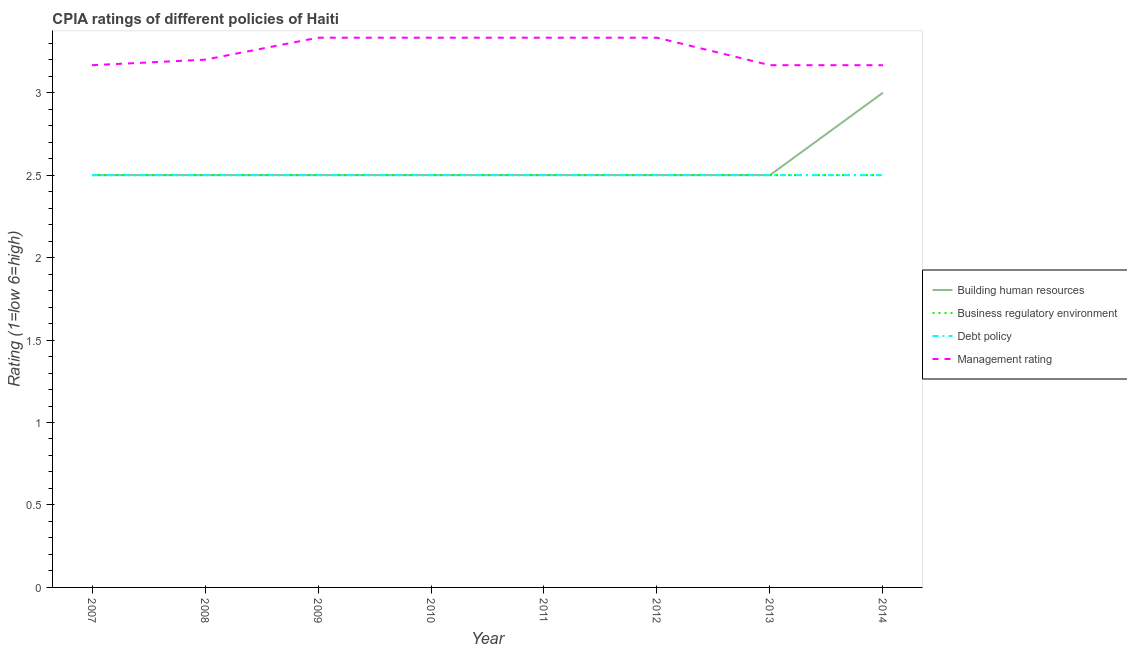How many different coloured lines are there?
Ensure brevity in your answer.  4. Is the number of lines equal to the number of legend labels?
Offer a very short reply. Yes. What is the cpia rating of building human resources in 2012?
Provide a short and direct response. 2.5. Across all years, what is the maximum cpia rating of business regulatory environment?
Offer a very short reply. 2.5. Across all years, what is the minimum cpia rating of building human resources?
Offer a very short reply. 2.5. In which year was the cpia rating of management maximum?
Your answer should be very brief. 2009. What is the total cpia rating of debt policy in the graph?
Offer a very short reply. 20. What is the difference between the cpia rating of business regulatory environment in 2012 and that in 2013?
Keep it short and to the point. 0. In the year 2009, what is the difference between the cpia rating of debt policy and cpia rating of management?
Offer a very short reply. -0.83. In how many years, is the cpia rating of debt policy greater than 1.5?
Provide a succinct answer. 8. Is the difference between the cpia rating of debt policy in 2012 and 2014 greater than the difference between the cpia rating of building human resources in 2012 and 2014?
Your response must be concise. Yes. What is the difference between the highest and the second highest cpia rating of building human resources?
Make the answer very short. 0.5. What is the difference between the highest and the lowest cpia rating of management?
Offer a very short reply. 0.17. Is the sum of the cpia rating of debt policy in 2007 and 2009 greater than the maximum cpia rating of business regulatory environment across all years?
Offer a very short reply. Yes. Is it the case that in every year, the sum of the cpia rating of building human resources and cpia rating of management is greater than the sum of cpia rating of debt policy and cpia rating of business regulatory environment?
Provide a short and direct response. Yes. Is it the case that in every year, the sum of the cpia rating of building human resources and cpia rating of business regulatory environment is greater than the cpia rating of debt policy?
Offer a very short reply. Yes. Does the cpia rating of management monotonically increase over the years?
Your response must be concise. No. Is the cpia rating of management strictly less than the cpia rating of business regulatory environment over the years?
Your answer should be very brief. No. How many lines are there?
Ensure brevity in your answer.  4. Are the values on the major ticks of Y-axis written in scientific E-notation?
Keep it short and to the point. No. Does the graph contain any zero values?
Your response must be concise. No. Does the graph contain grids?
Your answer should be very brief. No. Where does the legend appear in the graph?
Give a very brief answer. Center right. What is the title of the graph?
Keep it short and to the point. CPIA ratings of different policies of Haiti. Does "Taxes on exports" appear as one of the legend labels in the graph?
Offer a very short reply. No. What is the label or title of the Y-axis?
Provide a short and direct response. Rating (1=low 6=high). What is the Rating (1=low 6=high) in Building human resources in 2007?
Provide a succinct answer. 2.5. What is the Rating (1=low 6=high) of Management rating in 2007?
Provide a short and direct response. 3.17. What is the Rating (1=low 6=high) of Management rating in 2008?
Make the answer very short. 3.2. What is the Rating (1=low 6=high) in Management rating in 2009?
Provide a short and direct response. 3.33. What is the Rating (1=low 6=high) in Building human resources in 2010?
Your answer should be very brief. 2.5. What is the Rating (1=low 6=high) of Debt policy in 2010?
Give a very brief answer. 2.5. What is the Rating (1=low 6=high) in Management rating in 2010?
Provide a short and direct response. 3.33. What is the Rating (1=low 6=high) of Building human resources in 2011?
Offer a very short reply. 2.5. What is the Rating (1=low 6=high) in Debt policy in 2011?
Keep it short and to the point. 2.5. What is the Rating (1=low 6=high) of Management rating in 2011?
Your response must be concise. 3.33. What is the Rating (1=low 6=high) in Debt policy in 2012?
Make the answer very short. 2.5. What is the Rating (1=low 6=high) in Management rating in 2012?
Make the answer very short. 3.33. What is the Rating (1=low 6=high) in Business regulatory environment in 2013?
Your answer should be compact. 2.5. What is the Rating (1=low 6=high) of Management rating in 2013?
Your answer should be very brief. 3.17. What is the Rating (1=low 6=high) of Business regulatory environment in 2014?
Give a very brief answer. 2.5. What is the Rating (1=low 6=high) in Management rating in 2014?
Offer a terse response. 3.17. Across all years, what is the maximum Rating (1=low 6=high) in Debt policy?
Your answer should be very brief. 2.5. Across all years, what is the maximum Rating (1=low 6=high) of Management rating?
Provide a short and direct response. 3.33. Across all years, what is the minimum Rating (1=low 6=high) of Debt policy?
Offer a very short reply. 2.5. Across all years, what is the minimum Rating (1=low 6=high) in Management rating?
Ensure brevity in your answer.  3.17. What is the total Rating (1=low 6=high) of Building human resources in the graph?
Make the answer very short. 20.5. What is the total Rating (1=low 6=high) of Debt policy in the graph?
Give a very brief answer. 20. What is the total Rating (1=low 6=high) in Management rating in the graph?
Your answer should be compact. 26.03. What is the difference between the Rating (1=low 6=high) in Building human resources in 2007 and that in 2008?
Your answer should be compact. 0. What is the difference between the Rating (1=low 6=high) of Debt policy in 2007 and that in 2008?
Your response must be concise. 0. What is the difference between the Rating (1=low 6=high) in Management rating in 2007 and that in 2008?
Provide a succinct answer. -0.03. What is the difference between the Rating (1=low 6=high) in Debt policy in 2007 and that in 2009?
Your response must be concise. 0. What is the difference between the Rating (1=low 6=high) of Management rating in 2007 and that in 2009?
Offer a very short reply. -0.17. What is the difference between the Rating (1=low 6=high) in Building human resources in 2007 and that in 2010?
Give a very brief answer. 0. What is the difference between the Rating (1=low 6=high) in Business regulatory environment in 2007 and that in 2010?
Provide a short and direct response. 0. What is the difference between the Rating (1=low 6=high) in Debt policy in 2007 and that in 2010?
Offer a terse response. 0. What is the difference between the Rating (1=low 6=high) in Management rating in 2007 and that in 2010?
Offer a very short reply. -0.17. What is the difference between the Rating (1=low 6=high) in Building human resources in 2007 and that in 2011?
Make the answer very short. 0. What is the difference between the Rating (1=low 6=high) in Debt policy in 2007 and that in 2011?
Your answer should be compact. 0. What is the difference between the Rating (1=low 6=high) of Building human resources in 2007 and that in 2012?
Your answer should be compact. 0. What is the difference between the Rating (1=low 6=high) of Business regulatory environment in 2007 and that in 2012?
Your answer should be compact. 0. What is the difference between the Rating (1=low 6=high) of Debt policy in 2007 and that in 2012?
Your answer should be very brief. 0. What is the difference between the Rating (1=low 6=high) of Management rating in 2007 and that in 2012?
Provide a short and direct response. -0.17. What is the difference between the Rating (1=low 6=high) of Building human resources in 2007 and that in 2013?
Provide a short and direct response. 0. What is the difference between the Rating (1=low 6=high) of Business regulatory environment in 2007 and that in 2013?
Your answer should be compact. 0. What is the difference between the Rating (1=low 6=high) in Debt policy in 2007 and that in 2013?
Offer a very short reply. 0. What is the difference between the Rating (1=low 6=high) in Management rating in 2007 and that in 2013?
Ensure brevity in your answer.  0. What is the difference between the Rating (1=low 6=high) of Building human resources in 2007 and that in 2014?
Provide a short and direct response. -0.5. What is the difference between the Rating (1=low 6=high) in Business regulatory environment in 2007 and that in 2014?
Give a very brief answer. 0. What is the difference between the Rating (1=low 6=high) of Debt policy in 2007 and that in 2014?
Your answer should be very brief. 0. What is the difference between the Rating (1=low 6=high) of Management rating in 2007 and that in 2014?
Make the answer very short. -0. What is the difference between the Rating (1=low 6=high) in Business regulatory environment in 2008 and that in 2009?
Give a very brief answer. 0. What is the difference between the Rating (1=low 6=high) of Management rating in 2008 and that in 2009?
Provide a short and direct response. -0.13. What is the difference between the Rating (1=low 6=high) in Debt policy in 2008 and that in 2010?
Keep it short and to the point. 0. What is the difference between the Rating (1=low 6=high) of Management rating in 2008 and that in 2010?
Your answer should be compact. -0.13. What is the difference between the Rating (1=low 6=high) in Debt policy in 2008 and that in 2011?
Provide a succinct answer. 0. What is the difference between the Rating (1=low 6=high) in Management rating in 2008 and that in 2011?
Your response must be concise. -0.13. What is the difference between the Rating (1=low 6=high) in Business regulatory environment in 2008 and that in 2012?
Provide a short and direct response. 0. What is the difference between the Rating (1=low 6=high) in Management rating in 2008 and that in 2012?
Give a very brief answer. -0.13. What is the difference between the Rating (1=low 6=high) of Building human resources in 2008 and that in 2013?
Provide a succinct answer. 0. What is the difference between the Rating (1=low 6=high) in Business regulatory environment in 2008 and that in 2013?
Your answer should be very brief. 0. What is the difference between the Rating (1=low 6=high) of Building human resources in 2008 and that in 2014?
Offer a terse response. -0.5. What is the difference between the Rating (1=low 6=high) of Business regulatory environment in 2008 and that in 2014?
Your answer should be compact. 0. What is the difference between the Rating (1=low 6=high) in Debt policy in 2008 and that in 2014?
Provide a succinct answer. 0. What is the difference between the Rating (1=low 6=high) in Management rating in 2008 and that in 2014?
Make the answer very short. 0.03. What is the difference between the Rating (1=low 6=high) in Building human resources in 2009 and that in 2010?
Ensure brevity in your answer.  0. What is the difference between the Rating (1=low 6=high) in Debt policy in 2009 and that in 2010?
Your answer should be compact. 0. What is the difference between the Rating (1=low 6=high) of Management rating in 2009 and that in 2011?
Your response must be concise. 0. What is the difference between the Rating (1=low 6=high) of Business regulatory environment in 2009 and that in 2012?
Provide a succinct answer. 0. What is the difference between the Rating (1=low 6=high) of Debt policy in 2009 and that in 2012?
Make the answer very short. 0. What is the difference between the Rating (1=low 6=high) in Building human resources in 2009 and that in 2013?
Ensure brevity in your answer.  0. What is the difference between the Rating (1=low 6=high) in Business regulatory environment in 2009 and that in 2013?
Provide a succinct answer. 0. What is the difference between the Rating (1=low 6=high) in Debt policy in 2009 and that in 2013?
Provide a short and direct response. 0. What is the difference between the Rating (1=low 6=high) in Management rating in 2009 and that in 2013?
Make the answer very short. 0.17. What is the difference between the Rating (1=low 6=high) of Building human resources in 2009 and that in 2014?
Your answer should be compact. -0.5. What is the difference between the Rating (1=low 6=high) of Debt policy in 2009 and that in 2014?
Ensure brevity in your answer.  0. What is the difference between the Rating (1=low 6=high) in Building human resources in 2010 and that in 2011?
Your answer should be compact. 0. What is the difference between the Rating (1=low 6=high) in Debt policy in 2010 and that in 2012?
Ensure brevity in your answer.  0. What is the difference between the Rating (1=low 6=high) in Management rating in 2010 and that in 2012?
Offer a very short reply. 0. What is the difference between the Rating (1=low 6=high) in Building human resources in 2010 and that in 2013?
Offer a very short reply. 0. What is the difference between the Rating (1=low 6=high) of Management rating in 2010 and that in 2013?
Your answer should be compact. 0.17. What is the difference between the Rating (1=low 6=high) in Business regulatory environment in 2010 and that in 2014?
Ensure brevity in your answer.  0. What is the difference between the Rating (1=low 6=high) in Business regulatory environment in 2011 and that in 2012?
Your answer should be very brief. 0. What is the difference between the Rating (1=low 6=high) in Debt policy in 2011 and that in 2012?
Make the answer very short. 0. What is the difference between the Rating (1=low 6=high) of Management rating in 2011 and that in 2012?
Your answer should be very brief. 0. What is the difference between the Rating (1=low 6=high) in Building human resources in 2011 and that in 2014?
Keep it short and to the point. -0.5. What is the difference between the Rating (1=low 6=high) of Business regulatory environment in 2011 and that in 2014?
Offer a very short reply. 0. What is the difference between the Rating (1=low 6=high) in Debt policy in 2011 and that in 2014?
Provide a succinct answer. 0. What is the difference between the Rating (1=low 6=high) of Management rating in 2011 and that in 2014?
Your response must be concise. 0.17. What is the difference between the Rating (1=low 6=high) in Building human resources in 2012 and that in 2013?
Provide a succinct answer. 0. What is the difference between the Rating (1=low 6=high) in Business regulatory environment in 2012 and that in 2013?
Your answer should be very brief. 0. What is the difference between the Rating (1=low 6=high) in Management rating in 2012 and that in 2013?
Provide a short and direct response. 0.17. What is the difference between the Rating (1=low 6=high) in Debt policy in 2012 and that in 2014?
Keep it short and to the point. 0. What is the difference between the Rating (1=low 6=high) in Building human resources in 2013 and that in 2014?
Your response must be concise. -0.5. What is the difference between the Rating (1=low 6=high) of Debt policy in 2013 and that in 2014?
Your response must be concise. 0. What is the difference between the Rating (1=low 6=high) in Building human resources in 2007 and the Rating (1=low 6=high) in Business regulatory environment in 2008?
Offer a very short reply. 0. What is the difference between the Rating (1=low 6=high) in Building human resources in 2007 and the Rating (1=low 6=high) in Management rating in 2008?
Provide a succinct answer. -0.7. What is the difference between the Rating (1=low 6=high) of Debt policy in 2007 and the Rating (1=low 6=high) of Management rating in 2008?
Provide a succinct answer. -0.7. What is the difference between the Rating (1=low 6=high) of Building human resources in 2007 and the Rating (1=low 6=high) of Business regulatory environment in 2009?
Provide a short and direct response. 0. What is the difference between the Rating (1=low 6=high) in Building human resources in 2007 and the Rating (1=low 6=high) in Debt policy in 2009?
Provide a short and direct response. 0. What is the difference between the Rating (1=low 6=high) of Building human resources in 2007 and the Rating (1=low 6=high) of Management rating in 2009?
Provide a succinct answer. -0.83. What is the difference between the Rating (1=low 6=high) in Business regulatory environment in 2007 and the Rating (1=low 6=high) in Debt policy in 2009?
Ensure brevity in your answer.  0. What is the difference between the Rating (1=low 6=high) of Debt policy in 2007 and the Rating (1=low 6=high) of Management rating in 2009?
Your response must be concise. -0.83. What is the difference between the Rating (1=low 6=high) of Building human resources in 2007 and the Rating (1=low 6=high) of Business regulatory environment in 2010?
Offer a terse response. 0. What is the difference between the Rating (1=low 6=high) in Building human resources in 2007 and the Rating (1=low 6=high) in Debt policy in 2010?
Offer a very short reply. 0. What is the difference between the Rating (1=low 6=high) of Building human resources in 2007 and the Rating (1=low 6=high) of Management rating in 2010?
Provide a succinct answer. -0.83. What is the difference between the Rating (1=low 6=high) in Building human resources in 2007 and the Rating (1=low 6=high) in Business regulatory environment in 2011?
Your answer should be compact. 0. What is the difference between the Rating (1=low 6=high) of Building human resources in 2007 and the Rating (1=low 6=high) of Debt policy in 2011?
Provide a succinct answer. 0. What is the difference between the Rating (1=low 6=high) in Business regulatory environment in 2007 and the Rating (1=low 6=high) in Debt policy in 2011?
Provide a short and direct response. 0. What is the difference between the Rating (1=low 6=high) in Business regulatory environment in 2007 and the Rating (1=low 6=high) in Management rating in 2011?
Keep it short and to the point. -0.83. What is the difference between the Rating (1=low 6=high) in Building human resources in 2007 and the Rating (1=low 6=high) in Business regulatory environment in 2012?
Provide a short and direct response. 0. What is the difference between the Rating (1=low 6=high) in Building human resources in 2007 and the Rating (1=low 6=high) in Debt policy in 2012?
Ensure brevity in your answer.  0. What is the difference between the Rating (1=low 6=high) of Building human resources in 2007 and the Rating (1=low 6=high) of Management rating in 2012?
Your answer should be compact. -0.83. What is the difference between the Rating (1=low 6=high) of Business regulatory environment in 2007 and the Rating (1=low 6=high) of Debt policy in 2012?
Provide a succinct answer. 0. What is the difference between the Rating (1=low 6=high) of Business regulatory environment in 2007 and the Rating (1=low 6=high) of Management rating in 2012?
Give a very brief answer. -0.83. What is the difference between the Rating (1=low 6=high) in Business regulatory environment in 2007 and the Rating (1=low 6=high) in Debt policy in 2013?
Keep it short and to the point. 0. What is the difference between the Rating (1=low 6=high) in Debt policy in 2007 and the Rating (1=low 6=high) in Management rating in 2013?
Your answer should be compact. -0.67. What is the difference between the Rating (1=low 6=high) of Business regulatory environment in 2007 and the Rating (1=low 6=high) of Debt policy in 2014?
Offer a very short reply. 0. What is the difference between the Rating (1=low 6=high) in Business regulatory environment in 2007 and the Rating (1=low 6=high) in Management rating in 2014?
Provide a short and direct response. -0.67. What is the difference between the Rating (1=low 6=high) in Building human resources in 2008 and the Rating (1=low 6=high) in Management rating in 2009?
Your answer should be very brief. -0.83. What is the difference between the Rating (1=low 6=high) in Business regulatory environment in 2008 and the Rating (1=low 6=high) in Debt policy in 2009?
Provide a short and direct response. 0. What is the difference between the Rating (1=low 6=high) of Business regulatory environment in 2008 and the Rating (1=low 6=high) of Management rating in 2009?
Ensure brevity in your answer.  -0.83. What is the difference between the Rating (1=low 6=high) of Debt policy in 2008 and the Rating (1=low 6=high) of Management rating in 2009?
Offer a very short reply. -0.83. What is the difference between the Rating (1=low 6=high) of Building human resources in 2008 and the Rating (1=low 6=high) of Debt policy in 2010?
Provide a succinct answer. 0. What is the difference between the Rating (1=low 6=high) in Building human resources in 2008 and the Rating (1=low 6=high) in Management rating in 2010?
Give a very brief answer. -0.83. What is the difference between the Rating (1=low 6=high) in Business regulatory environment in 2008 and the Rating (1=low 6=high) in Management rating in 2010?
Offer a very short reply. -0.83. What is the difference between the Rating (1=low 6=high) in Debt policy in 2008 and the Rating (1=low 6=high) in Management rating in 2010?
Offer a terse response. -0.83. What is the difference between the Rating (1=low 6=high) of Building human resources in 2008 and the Rating (1=low 6=high) of Debt policy in 2011?
Offer a terse response. 0. What is the difference between the Rating (1=low 6=high) of Building human resources in 2008 and the Rating (1=low 6=high) of Management rating in 2011?
Make the answer very short. -0.83. What is the difference between the Rating (1=low 6=high) in Business regulatory environment in 2008 and the Rating (1=low 6=high) in Debt policy in 2011?
Offer a terse response. 0. What is the difference between the Rating (1=low 6=high) in Building human resources in 2008 and the Rating (1=low 6=high) in Business regulatory environment in 2012?
Make the answer very short. 0. What is the difference between the Rating (1=low 6=high) of Building human resources in 2008 and the Rating (1=low 6=high) of Management rating in 2012?
Your answer should be compact. -0.83. What is the difference between the Rating (1=low 6=high) of Business regulatory environment in 2008 and the Rating (1=low 6=high) of Debt policy in 2012?
Your answer should be compact. 0. What is the difference between the Rating (1=low 6=high) in Building human resources in 2008 and the Rating (1=low 6=high) in Business regulatory environment in 2013?
Keep it short and to the point. 0. What is the difference between the Rating (1=low 6=high) in Building human resources in 2008 and the Rating (1=low 6=high) in Debt policy in 2013?
Give a very brief answer. 0. What is the difference between the Rating (1=low 6=high) of Business regulatory environment in 2008 and the Rating (1=low 6=high) of Management rating in 2013?
Your answer should be compact. -0.67. What is the difference between the Rating (1=low 6=high) in Debt policy in 2008 and the Rating (1=low 6=high) in Management rating in 2013?
Give a very brief answer. -0.67. What is the difference between the Rating (1=low 6=high) in Building human resources in 2008 and the Rating (1=low 6=high) in Business regulatory environment in 2014?
Your response must be concise. 0. What is the difference between the Rating (1=low 6=high) of Building human resources in 2008 and the Rating (1=low 6=high) of Debt policy in 2014?
Your answer should be very brief. 0. What is the difference between the Rating (1=low 6=high) in Business regulatory environment in 2008 and the Rating (1=low 6=high) in Debt policy in 2014?
Offer a very short reply. 0. What is the difference between the Rating (1=low 6=high) of Business regulatory environment in 2008 and the Rating (1=low 6=high) of Management rating in 2014?
Your answer should be very brief. -0.67. What is the difference between the Rating (1=low 6=high) in Building human resources in 2009 and the Rating (1=low 6=high) in Debt policy in 2010?
Give a very brief answer. 0. What is the difference between the Rating (1=low 6=high) in Building human resources in 2009 and the Rating (1=low 6=high) in Business regulatory environment in 2011?
Offer a very short reply. 0. What is the difference between the Rating (1=low 6=high) in Building human resources in 2009 and the Rating (1=low 6=high) in Debt policy in 2011?
Provide a short and direct response. 0. What is the difference between the Rating (1=low 6=high) in Building human resources in 2009 and the Rating (1=low 6=high) in Management rating in 2011?
Your response must be concise. -0.83. What is the difference between the Rating (1=low 6=high) of Business regulatory environment in 2009 and the Rating (1=low 6=high) of Debt policy in 2011?
Offer a very short reply. 0. What is the difference between the Rating (1=low 6=high) in Building human resources in 2009 and the Rating (1=low 6=high) in Business regulatory environment in 2012?
Your response must be concise. 0. What is the difference between the Rating (1=low 6=high) of Debt policy in 2009 and the Rating (1=low 6=high) of Management rating in 2012?
Give a very brief answer. -0.83. What is the difference between the Rating (1=low 6=high) in Building human resources in 2009 and the Rating (1=low 6=high) in Business regulatory environment in 2013?
Give a very brief answer. 0. What is the difference between the Rating (1=low 6=high) of Building human resources in 2009 and the Rating (1=low 6=high) of Debt policy in 2013?
Offer a very short reply. 0. What is the difference between the Rating (1=low 6=high) in Business regulatory environment in 2009 and the Rating (1=low 6=high) in Debt policy in 2013?
Provide a short and direct response. 0. What is the difference between the Rating (1=low 6=high) of Business regulatory environment in 2009 and the Rating (1=low 6=high) of Management rating in 2013?
Provide a short and direct response. -0.67. What is the difference between the Rating (1=low 6=high) in Debt policy in 2009 and the Rating (1=low 6=high) in Management rating in 2013?
Your response must be concise. -0.67. What is the difference between the Rating (1=low 6=high) of Building human resources in 2009 and the Rating (1=low 6=high) of Business regulatory environment in 2014?
Your answer should be very brief. 0. What is the difference between the Rating (1=low 6=high) of Building human resources in 2009 and the Rating (1=low 6=high) of Debt policy in 2014?
Provide a succinct answer. 0. What is the difference between the Rating (1=low 6=high) in Building human resources in 2009 and the Rating (1=low 6=high) in Management rating in 2014?
Make the answer very short. -0.67. What is the difference between the Rating (1=low 6=high) of Business regulatory environment in 2009 and the Rating (1=low 6=high) of Debt policy in 2014?
Your answer should be compact. 0. What is the difference between the Rating (1=low 6=high) of Business regulatory environment in 2009 and the Rating (1=low 6=high) of Management rating in 2014?
Give a very brief answer. -0.67. What is the difference between the Rating (1=low 6=high) of Debt policy in 2009 and the Rating (1=low 6=high) of Management rating in 2014?
Your response must be concise. -0.67. What is the difference between the Rating (1=low 6=high) of Building human resources in 2010 and the Rating (1=low 6=high) of Debt policy in 2011?
Provide a succinct answer. 0. What is the difference between the Rating (1=low 6=high) in Building human resources in 2010 and the Rating (1=low 6=high) in Management rating in 2011?
Your answer should be very brief. -0.83. What is the difference between the Rating (1=low 6=high) of Building human resources in 2010 and the Rating (1=low 6=high) of Business regulatory environment in 2012?
Your response must be concise. 0. What is the difference between the Rating (1=low 6=high) of Building human resources in 2010 and the Rating (1=low 6=high) of Management rating in 2012?
Make the answer very short. -0.83. What is the difference between the Rating (1=low 6=high) of Business regulatory environment in 2010 and the Rating (1=low 6=high) of Debt policy in 2012?
Offer a terse response. 0. What is the difference between the Rating (1=low 6=high) in Building human resources in 2010 and the Rating (1=low 6=high) in Business regulatory environment in 2013?
Provide a succinct answer. 0. What is the difference between the Rating (1=low 6=high) of Building human resources in 2010 and the Rating (1=low 6=high) of Debt policy in 2013?
Your answer should be very brief. 0. What is the difference between the Rating (1=low 6=high) in Building human resources in 2010 and the Rating (1=low 6=high) in Management rating in 2013?
Your answer should be very brief. -0.67. What is the difference between the Rating (1=low 6=high) of Business regulatory environment in 2010 and the Rating (1=low 6=high) of Debt policy in 2013?
Make the answer very short. 0. What is the difference between the Rating (1=low 6=high) of Business regulatory environment in 2010 and the Rating (1=low 6=high) of Management rating in 2013?
Your answer should be compact. -0.67. What is the difference between the Rating (1=low 6=high) in Debt policy in 2010 and the Rating (1=low 6=high) in Management rating in 2013?
Your answer should be very brief. -0.67. What is the difference between the Rating (1=low 6=high) of Building human resources in 2010 and the Rating (1=low 6=high) of Management rating in 2014?
Your answer should be compact. -0.67. What is the difference between the Rating (1=low 6=high) of Business regulatory environment in 2010 and the Rating (1=low 6=high) of Management rating in 2014?
Give a very brief answer. -0.67. What is the difference between the Rating (1=low 6=high) of Debt policy in 2010 and the Rating (1=low 6=high) of Management rating in 2014?
Offer a very short reply. -0.67. What is the difference between the Rating (1=low 6=high) of Building human resources in 2011 and the Rating (1=low 6=high) of Management rating in 2012?
Offer a very short reply. -0.83. What is the difference between the Rating (1=low 6=high) in Business regulatory environment in 2011 and the Rating (1=low 6=high) in Debt policy in 2012?
Make the answer very short. 0. What is the difference between the Rating (1=low 6=high) of Building human resources in 2011 and the Rating (1=low 6=high) of Management rating in 2013?
Make the answer very short. -0.67. What is the difference between the Rating (1=low 6=high) in Building human resources in 2011 and the Rating (1=low 6=high) in Business regulatory environment in 2014?
Ensure brevity in your answer.  0. What is the difference between the Rating (1=low 6=high) of Building human resources in 2011 and the Rating (1=low 6=high) of Debt policy in 2014?
Offer a very short reply. 0. What is the difference between the Rating (1=low 6=high) in Building human resources in 2011 and the Rating (1=low 6=high) in Management rating in 2014?
Give a very brief answer. -0.67. What is the difference between the Rating (1=low 6=high) in Business regulatory environment in 2011 and the Rating (1=low 6=high) in Management rating in 2014?
Give a very brief answer. -0.67. What is the difference between the Rating (1=low 6=high) of Building human resources in 2012 and the Rating (1=low 6=high) of Business regulatory environment in 2013?
Ensure brevity in your answer.  0. What is the difference between the Rating (1=low 6=high) in Building human resources in 2012 and the Rating (1=low 6=high) in Debt policy in 2013?
Ensure brevity in your answer.  0. What is the difference between the Rating (1=low 6=high) of Building human resources in 2012 and the Rating (1=low 6=high) of Management rating in 2013?
Your answer should be compact. -0.67. What is the difference between the Rating (1=low 6=high) in Business regulatory environment in 2012 and the Rating (1=low 6=high) in Management rating in 2013?
Your answer should be very brief. -0.67. What is the difference between the Rating (1=low 6=high) of Debt policy in 2012 and the Rating (1=low 6=high) of Management rating in 2013?
Offer a terse response. -0.67. What is the difference between the Rating (1=low 6=high) of Building human resources in 2012 and the Rating (1=low 6=high) of Management rating in 2014?
Ensure brevity in your answer.  -0.67. What is the difference between the Rating (1=low 6=high) in Business regulatory environment in 2012 and the Rating (1=low 6=high) in Debt policy in 2014?
Your answer should be compact. 0. What is the difference between the Rating (1=low 6=high) in Business regulatory environment in 2012 and the Rating (1=low 6=high) in Management rating in 2014?
Provide a short and direct response. -0.67. What is the difference between the Rating (1=low 6=high) in Debt policy in 2012 and the Rating (1=low 6=high) in Management rating in 2014?
Your response must be concise. -0.67. What is the difference between the Rating (1=low 6=high) of Building human resources in 2013 and the Rating (1=low 6=high) of Business regulatory environment in 2014?
Offer a terse response. 0. What is the difference between the Rating (1=low 6=high) in Business regulatory environment in 2013 and the Rating (1=low 6=high) in Debt policy in 2014?
Make the answer very short. 0. What is the average Rating (1=low 6=high) in Building human resources per year?
Offer a terse response. 2.56. What is the average Rating (1=low 6=high) of Management rating per year?
Offer a very short reply. 3.25. In the year 2007, what is the difference between the Rating (1=low 6=high) of Building human resources and Rating (1=low 6=high) of Business regulatory environment?
Ensure brevity in your answer.  0. In the year 2007, what is the difference between the Rating (1=low 6=high) of Building human resources and Rating (1=low 6=high) of Management rating?
Your answer should be compact. -0.67. In the year 2007, what is the difference between the Rating (1=low 6=high) of Business regulatory environment and Rating (1=low 6=high) of Debt policy?
Give a very brief answer. 0. In the year 2007, what is the difference between the Rating (1=low 6=high) of Debt policy and Rating (1=low 6=high) of Management rating?
Give a very brief answer. -0.67. In the year 2008, what is the difference between the Rating (1=low 6=high) of Building human resources and Rating (1=low 6=high) of Debt policy?
Your answer should be compact. 0. In the year 2008, what is the difference between the Rating (1=low 6=high) in Building human resources and Rating (1=low 6=high) in Management rating?
Make the answer very short. -0.7. In the year 2008, what is the difference between the Rating (1=low 6=high) in Business regulatory environment and Rating (1=low 6=high) in Management rating?
Make the answer very short. -0.7. In the year 2008, what is the difference between the Rating (1=low 6=high) of Debt policy and Rating (1=low 6=high) of Management rating?
Give a very brief answer. -0.7. In the year 2009, what is the difference between the Rating (1=low 6=high) of Building human resources and Rating (1=low 6=high) of Business regulatory environment?
Provide a short and direct response. 0. In the year 2009, what is the difference between the Rating (1=low 6=high) in Building human resources and Rating (1=low 6=high) in Management rating?
Offer a terse response. -0.83. In the year 2009, what is the difference between the Rating (1=low 6=high) in Business regulatory environment and Rating (1=low 6=high) in Debt policy?
Make the answer very short. 0. In the year 2009, what is the difference between the Rating (1=low 6=high) of Business regulatory environment and Rating (1=low 6=high) of Management rating?
Give a very brief answer. -0.83. In the year 2009, what is the difference between the Rating (1=low 6=high) of Debt policy and Rating (1=low 6=high) of Management rating?
Give a very brief answer. -0.83. In the year 2010, what is the difference between the Rating (1=low 6=high) of Building human resources and Rating (1=low 6=high) of Debt policy?
Provide a succinct answer. 0. In the year 2010, what is the difference between the Rating (1=low 6=high) in Business regulatory environment and Rating (1=low 6=high) in Debt policy?
Provide a succinct answer. 0. In the year 2010, what is the difference between the Rating (1=low 6=high) in Business regulatory environment and Rating (1=low 6=high) in Management rating?
Offer a very short reply. -0.83. In the year 2011, what is the difference between the Rating (1=low 6=high) of Building human resources and Rating (1=low 6=high) of Business regulatory environment?
Your response must be concise. 0. In the year 2011, what is the difference between the Rating (1=low 6=high) of Building human resources and Rating (1=low 6=high) of Management rating?
Make the answer very short. -0.83. In the year 2011, what is the difference between the Rating (1=low 6=high) of Business regulatory environment and Rating (1=low 6=high) of Debt policy?
Give a very brief answer. 0. In the year 2011, what is the difference between the Rating (1=low 6=high) of Debt policy and Rating (1=low 6=high) of Management rating?
Provide a succinct answer. -0.83. In the year 2012, what is the difference between the Rating (1=low 6=high) in Building human resources and Rating (1=low 6=high) in Business regulatory environment?
Make the answer very short. 0. In the year 2012, what is the difference between the Rating (1=low 6=high) in Building human resources and Rating (1=low 6=high) in Management rating?
Your response must be concise. -0.83. In the year 2012, what is the difference between the Rating (1=low 6=high) of Debt policy and Rating (1=low 6=high) of Management rating?
Keep it short and to the point. -0.83. In the year 2013, what is the difference between the Rating (1=low 6=high) in Building human resources and Rating (1=low 6=high) in Business regulatory environment?
Provide a short and direct response. 0. In the year 2013, what is the difference between the Rating (1=low 6=high) in Building human resources and Rating (1=low 6=high) in Debt policy?
Keep it short and to the point. 0. In the year 2013, what is the difference between the Rating (1=low 6=high) of Building human resources and Rating (1=low 6=high) of Management rating?
Your answer should be very brief. -0.67. In the year 2013, what is the difference between the Rating (1=low 6=high) of Business regulatory environment and Rating (1=low 6=high) of Management rating?
Ensure brevity in your answer.  -0.67. In the year 2014, what is the difference between the Rating (1=low 6=high) in Business regulatory environment and Rating (1=low 6=high) in Management rating?
Ensure brevity in your answer.  -0.67. In the year 2014, what is the difference between the Rating (1=low 6=high) in Debt policy and Rating (1=low 6=high) in Management rating?
Provide a succinct answer. -0.67. What is the ratio of the Rating (1=low 6=high) in Building human resources in 2007 to that in 2008?
Keep it short and to the point. 1. What is the ratio of the Rating (1=low 6=high) of Business regulatory environment in 2007 to that in 2008?
Your response must be concise. 1. What is the ratio of the Rating (1=low 6=high) of Management rating in 2007 to that in 2008?
Ensure brevity in your answer.  0.99. What is the ratio of the Rating (1=low 6=high) of Building human resources in 2007 to that in 2009?
Give a very brief answer. 1. What is the ratio of the Rating (1=low 6=high) in Business regulatory environment in 2007 to that in 2009?
Offer a terse response. 1. What is the ratio of the Rating (1=low 6=high) of Building human resources in 2007 to that in 2010?
Offer a terse response. 1. What is the ratio of the Rating (1=low 6=high) in Debt policy in 2007 to that in 2010?
Provide a succinct answer. 1. What is the ratio of the Rating (1=low 6=high) in Building human resources in 2007 to that in 2011?
Your answer should be compact. 1. What is the ratio of the Rating (1=low 6=high) of Debt policy in 2007 to that in 2011?
Offer a very short reply. 1. What is the ratio of the Rating (1=low 6=high) of Management rating in 2007 to that in 2011?
Give a very brief answer. 0.95. What is the ratio of the Rating (1=low 6=high) of Building human resources in 2007 to that in 2012?
Ensure brevity in your answer.  1. What is the ratio of the Rating (1=low 6=high) of Business regulatory environment in 2007 to that in 2012?
Your answer should be very brief. 1. What is the ratio of the Rating (1=low 6=high) in Management rating in 2007 to that in 2012?
Your answer should be compact. 0.95. What is the ratio of the Rating (1=low 6=high) of Business regulatory environment in 2007 to that in 2013?
Provide a succinct answer. 1. What is the ratio of the Rating (1=low 6=high) in Management rating in 2007 to that in 2013?
Make the answer very short. 1. What is the ratio of the Rating (1=low 6=high) of Building human resources in 2007 to that in 2014?
Offer a very short reply. 0.83. What is the ratio of the Rating (1=low 6=high) in Debt policy in 2008 to that in 2009?
Offer a very short reply. 1. What is the ratio of the Rating (1=low 6=high) of Building human resources in 2008 to that in 2010?
Give a very brief answer. 1. What is the ratio of the Rating (1=low 6=high) of Business regulatory environment in 2008 to that in 2010?
Your response must be concise. 1. What is the ratio of the Rating (1=low 6=high) in Management rating in 2008 to that in 2010?
Keep it short and to the point. 0.96. What is the ratio of the Rating (1=low 6=high) of Business regulatory environment in 2008 to that in 2011?
Ensure brevity in your answer.  1. What is the ratio of the Rating (1=low 6=high) of Debt policy in 2008 to that in 2011?
Provide a short and direct response. 1. What is the ratio of the Rating (1=low 6=high) in Business regulatory environment in 2008 to that in 2012?
Ensure brevity in your answer.  1. What is the ratio of the Rating (1=low 6=high) of Management rating in 2008 to that in 2012?
Your response must be concise. 0.96. What is the ratio of the Rating (1=low 6=high) in Management rating in 2008 to that in 2013?
Give a very brief answer. 1.01. What is the ratio of the Rating (1=low 6=high) in Debt policy in 2008 to that in 2014?
Offer a terse response. 1. What is the ratio of the Rating (1=low 6=high) of Management rating in 2008 to that in 2014?
Keep it short and to the point. 1.01. What is the ratio of the Rating (1=low 6=high) of Building human resources in 2009 to that in 2010?
Your response must be concise. 1. What is the ratio of the Rating (1=low 6=high) in Business regulatory environment in 2009 to that in 2010?
Make the answer very short. 1. What is the ratio of the Rating (1=low 6=high) in Building human resources in 2009 to that in 2011?
Your answer should be very brief. 1. What is the ratio of the Rating (1=low 6=high) in Debt policy in 2009 to that in 2011?
Ensure brevity in your answer.  1. What is the ratio of the Rating (1=low 6=high) of Management rating in 2009 to that in 2011?
Make the answer very short. 1. What is the ratio of the Rating (1=low 6=high) of Building human resources in 2009 to that in 2012?
Make the answer very short. 1. What is the ratio of the Rating (1=low 6=high) in Business regulatory environment in 2009 to that in 2012?
Ensure brevity in your answer.  1. What is the ratio of the Rating (1=low 6=high) in Debt policy in 2009 to that in 2012?
Your answer should be very brief. 1. What is the ratio of the Rating (1=low 6=high) of Debt policy in 2009 to that in 2013?
Offer a terse response. 1. What is the ratio of the Rating (1=low 6=high) of Management rating in 2009 to that in 2013?
Keep it short and to the point. 1.05. What is the ratio of the Rating (1=low 6=high) of Business regulatory environment in 2009 to that in 2014?
Keep it short and to the point. 1. What is the ratio of the Rating (1=low 6=high) of Debt policy in 2009 to that in 2014?
Ensure brevity in your answer.  1. What is the ratio of the Rating (1=low 6=high) of Management rating in 2009 to that in 2014?
Make the answer very short. 1.05. What is the ratio of the Rating (1=low 6=high) of Debt policy in 2010 to that in 2011?
Your response must be concise. 1. What is the ratio of the Rating (1=low 6=high) of Management rating in 2010 to that in 2011?
Your response must be concise. 1. What is the ratio of the Rating (1=low 6=high) of Debt policy in 2010 to that in 2012?
Provide a succinct answer. 1. What is the ratio of the Rating (1=low 6=high) of Management rating in 2010 to that in 2012?
Make the answer very short. 1. What is the ratio of the Rating (1=low 6=high) of Building human resources in 2010 to that in 2013?
Offer a terse response. 1. What is the ratio of the Rating (1=low 6=high) of Debt policy in 2010 to that in 2013?
Provide a succinct answer. 1. What is the ratio of the Rating (1=low 6=high) in Management rating in 2010 to that in 2013?
Keep it short and to the point. 1.05. What is the ratio of the Rating (1=low 6=high) of Building human resources in 2010 to that in 2014?
Ensure brevity in your answer.  0.83. What is the ratio of the Rating (1=low 6=high) in Business regulatory environment in 2010 to that in 2014?
Offer a very short reply. 1. What is the ratio of the Rating (1=low 6=high) of Debt policy in 2010 to that in 2014?
Give a very brief answer. 1. What is the ratio of the Rating (1=low 6=high) in Management rating in 2010 to that in 2014?
Your answer should be compact. 1.05. What is the ratio of the Rating (1=low 6=high) of Building human resources in 2011 to that in 2012?
Keep it short and to the point. 1. What is the ratio of the Rating (1=low 6=high) of Business regulatory environment in 2011 to that in 2012?
Offer a terse response. 1. What is the ratio of the Rating (1=low 6=high) in Debt policy in 2011 to that in 2013?
Offer a terse response. 1. What is the ratio of the Rating (1=low 6=high) of Management rating in 2011 to that in 2013?
Your answer should be compact. 1.05. What is the ratio of the Rating (1=low 6=high) in Building human resources in 2011 to that in 2014?
Offer a terse response. 0.83. What is the ratio of the Rating (1=low 6=high) in Business regulatory environment in 2011 to that in 2014?
Your answer should be compact. 1. What is the ratio of the Rating (1=low 6=high) in Management rating in 2011 to that in 2014?
Offer a very short reply. 1.05. What is the ratio of the Rating (1=low 6=high) in Business regulatory environment in 2012 to that in 2013?
Offer a terse response. 1. What is the ratio of the Rating (1=low 6=high) in Debt policy in 2012 to that in 2013?
Offer a very short reply. 1. What is the ratio of the Rating (1=low 6=high) of Management rating in 2012 to that in 2013?
Keep it short and to the point. 1.05. What is the ratio of the Rating (1=low 6=high) in Business regulatory environment in 2012 to that in 2014?
Your response must be concise. 1. What is the ratio of the Rating (1=low 6=high) in Debt policy in 2012 to that in 2014?
Your answer should be compact. 1. What is the ratio of the Rating (1=low 6=high) of Management rating in 2012 to that in 2014?
Provide a succinct answer. 1.05. What is the ratio of the Rating (1=low 6=high) in Debt policy in 2013 to that in 2014?
Your answer should be compact. 1. What is the ratio of the Rating (1=low 6=high) in Management rating in 2013 to that in 2014?
Your response must be concise. 1. What is the difference between the highest and the second highest Rating (1=low 6=high) of Building human resources?
Your response must be concise. 0.5. What is the difference between the highest and the second highest Rating (1=low 6=high) in Business regulatory environment?
Provide a succinct answer. 0. What is the difference between the highest and the second highest Rating (1=low 6=high) of Debt policy?
Your response must be concise. 0. What is the difference between the highest and the lowest Rating (1=low 6=high) of Business regulatory environment?
Your answer should be very brief. 0. What is the difference between the highest and the lowest Rating (1=low 6=high) in Management rating?
Offer a very short reply. 0.17. 